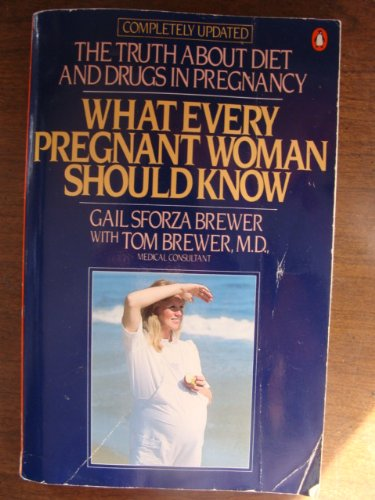Who wrote this book?
Answer the question using a single word or phrase. Gail Sforza Brewer What is the title of this book? What Every Pregnant Woman Should Know What is the genre of this book? Medical Books Is this a pharmaceutical book? Yes Is this a homosexuality book? No 